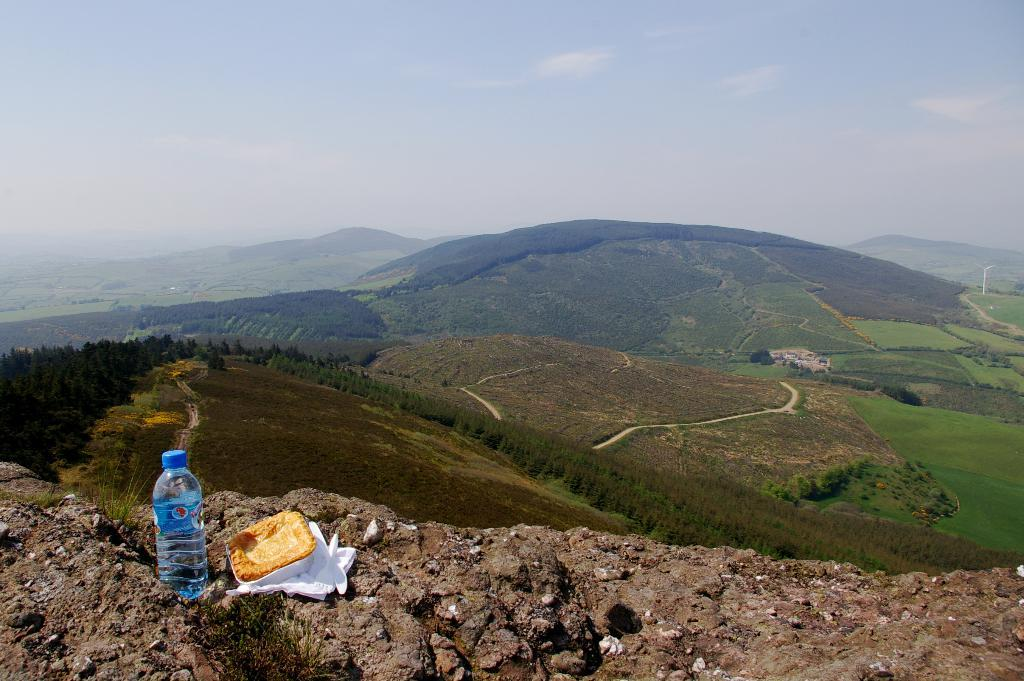What is located in the foreground of the image? There is a bottle in the foreground of the image. What else can be seen on the ground in the foreground? There is food, tissues, and spoons on the ground in the foreground. What can be seen in the background of the image? There are trees, mountains, and the sky visible in the background of the image. What is the condition of the sky in the background of the image? The sky in the background of the image has clouds. What type of plantation can be seen in the image? There is no plantation present in the image. Is there a rainstorm occurring in the image? There is no rainstorm depicted in the image; the sky has clouds, but it is not raining. 